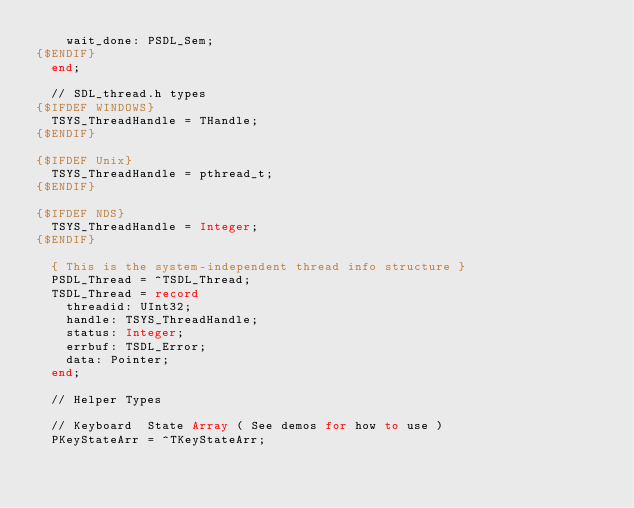<code> <loc_0><loc_0><loc_500><loc_500><_Pascal_>    wait_done: PSDL_Sem;
{$ENDIF}
  end;

  // SDL_thread.h types
{$IFDEF WINDOWS}
  TSYS_ThreadHandle = THandle;
{$ENDIF}

{$IFDEF Unix}
  TSYS_ThreadHandle = pthread_t;
{$ENDIF}

{$IFDEF NDS}
  TSYS_ThreadHandle = Integer;
{$ENDIF}

  { This is the system-independent thread info structure }
  PSDL_Thread = ^TSDL_Thread;
  TSDL_Thread = record
    threadid: UInt32;
    handle: TSYS_ThreadHandle;
    status: Integer;
    errbuf: TSDL_Error;
    data: Pointer;
  end;

  // Helper Types

  // Keyboard  State Array ( See demos for how to use )
  PKeyStateArr = ^TKeyStateArr;</code> 